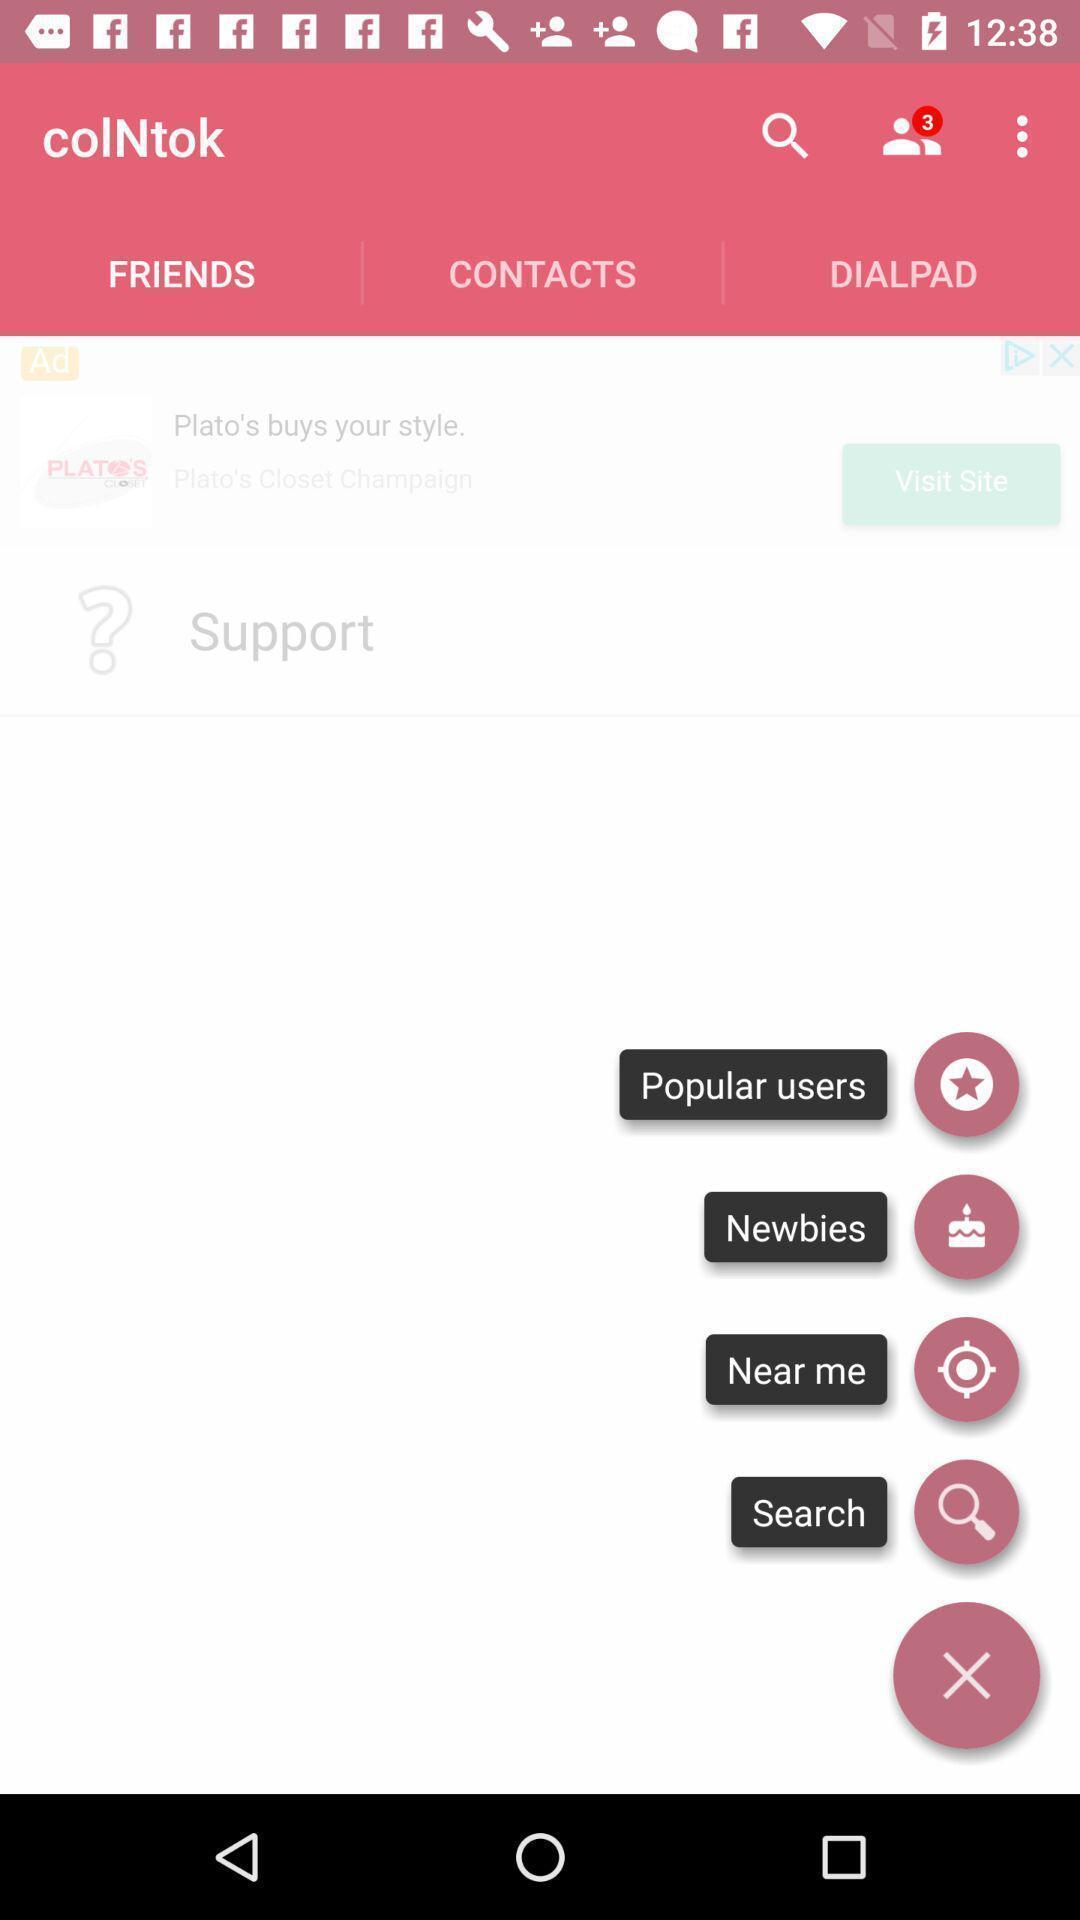Explain what's happening in this screen capture. Pop up displaying list of options. 